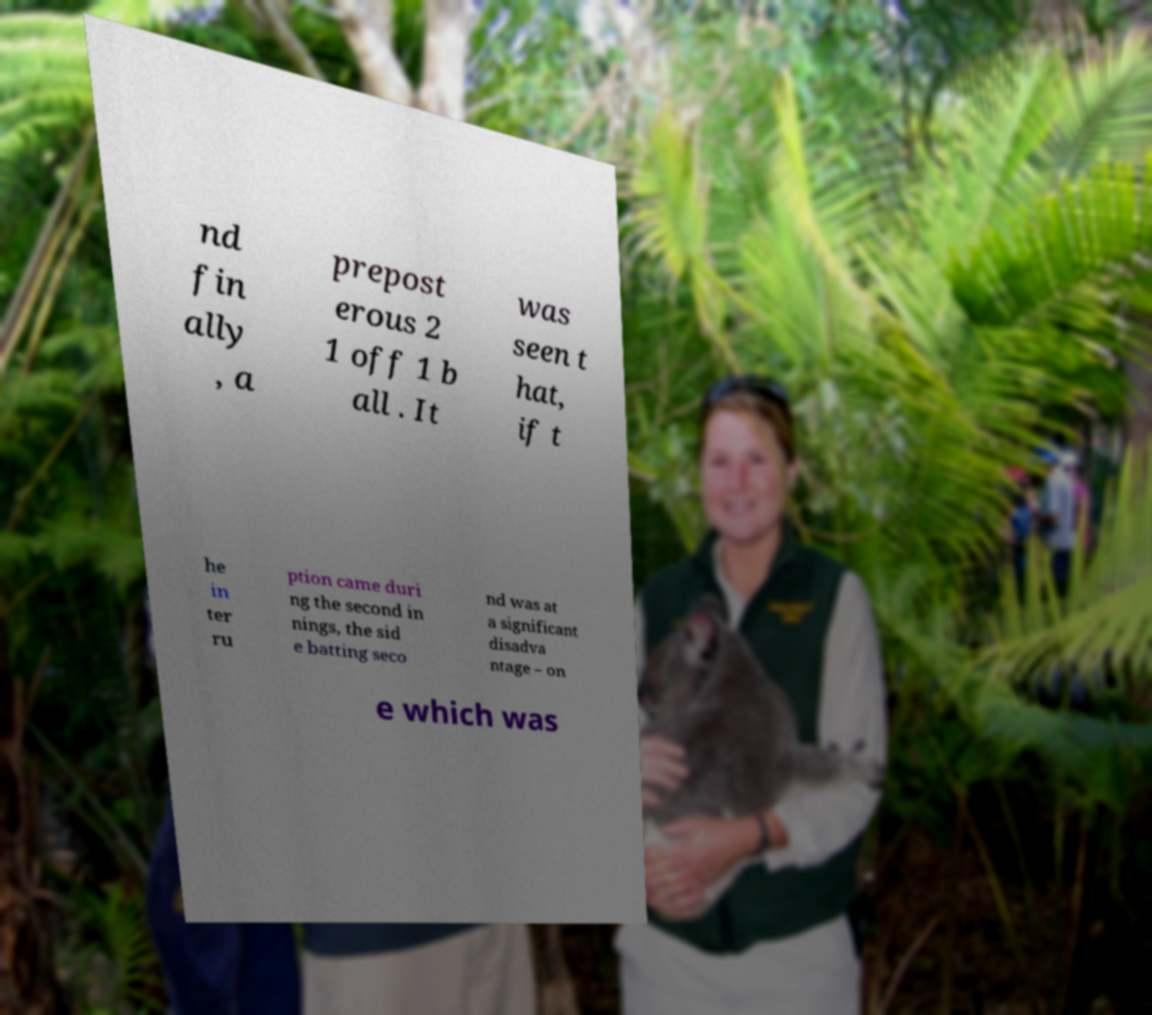Could you assist in decoding the text presented in this image and type it out clearly? nd fin ally , a prepost erous 2 1 off 1 b all . It was seen t hat, if t he in ter ru ption came duri ng the second in nings, the sid e batting seco nd was at a significant disadva ntage – on e which was 